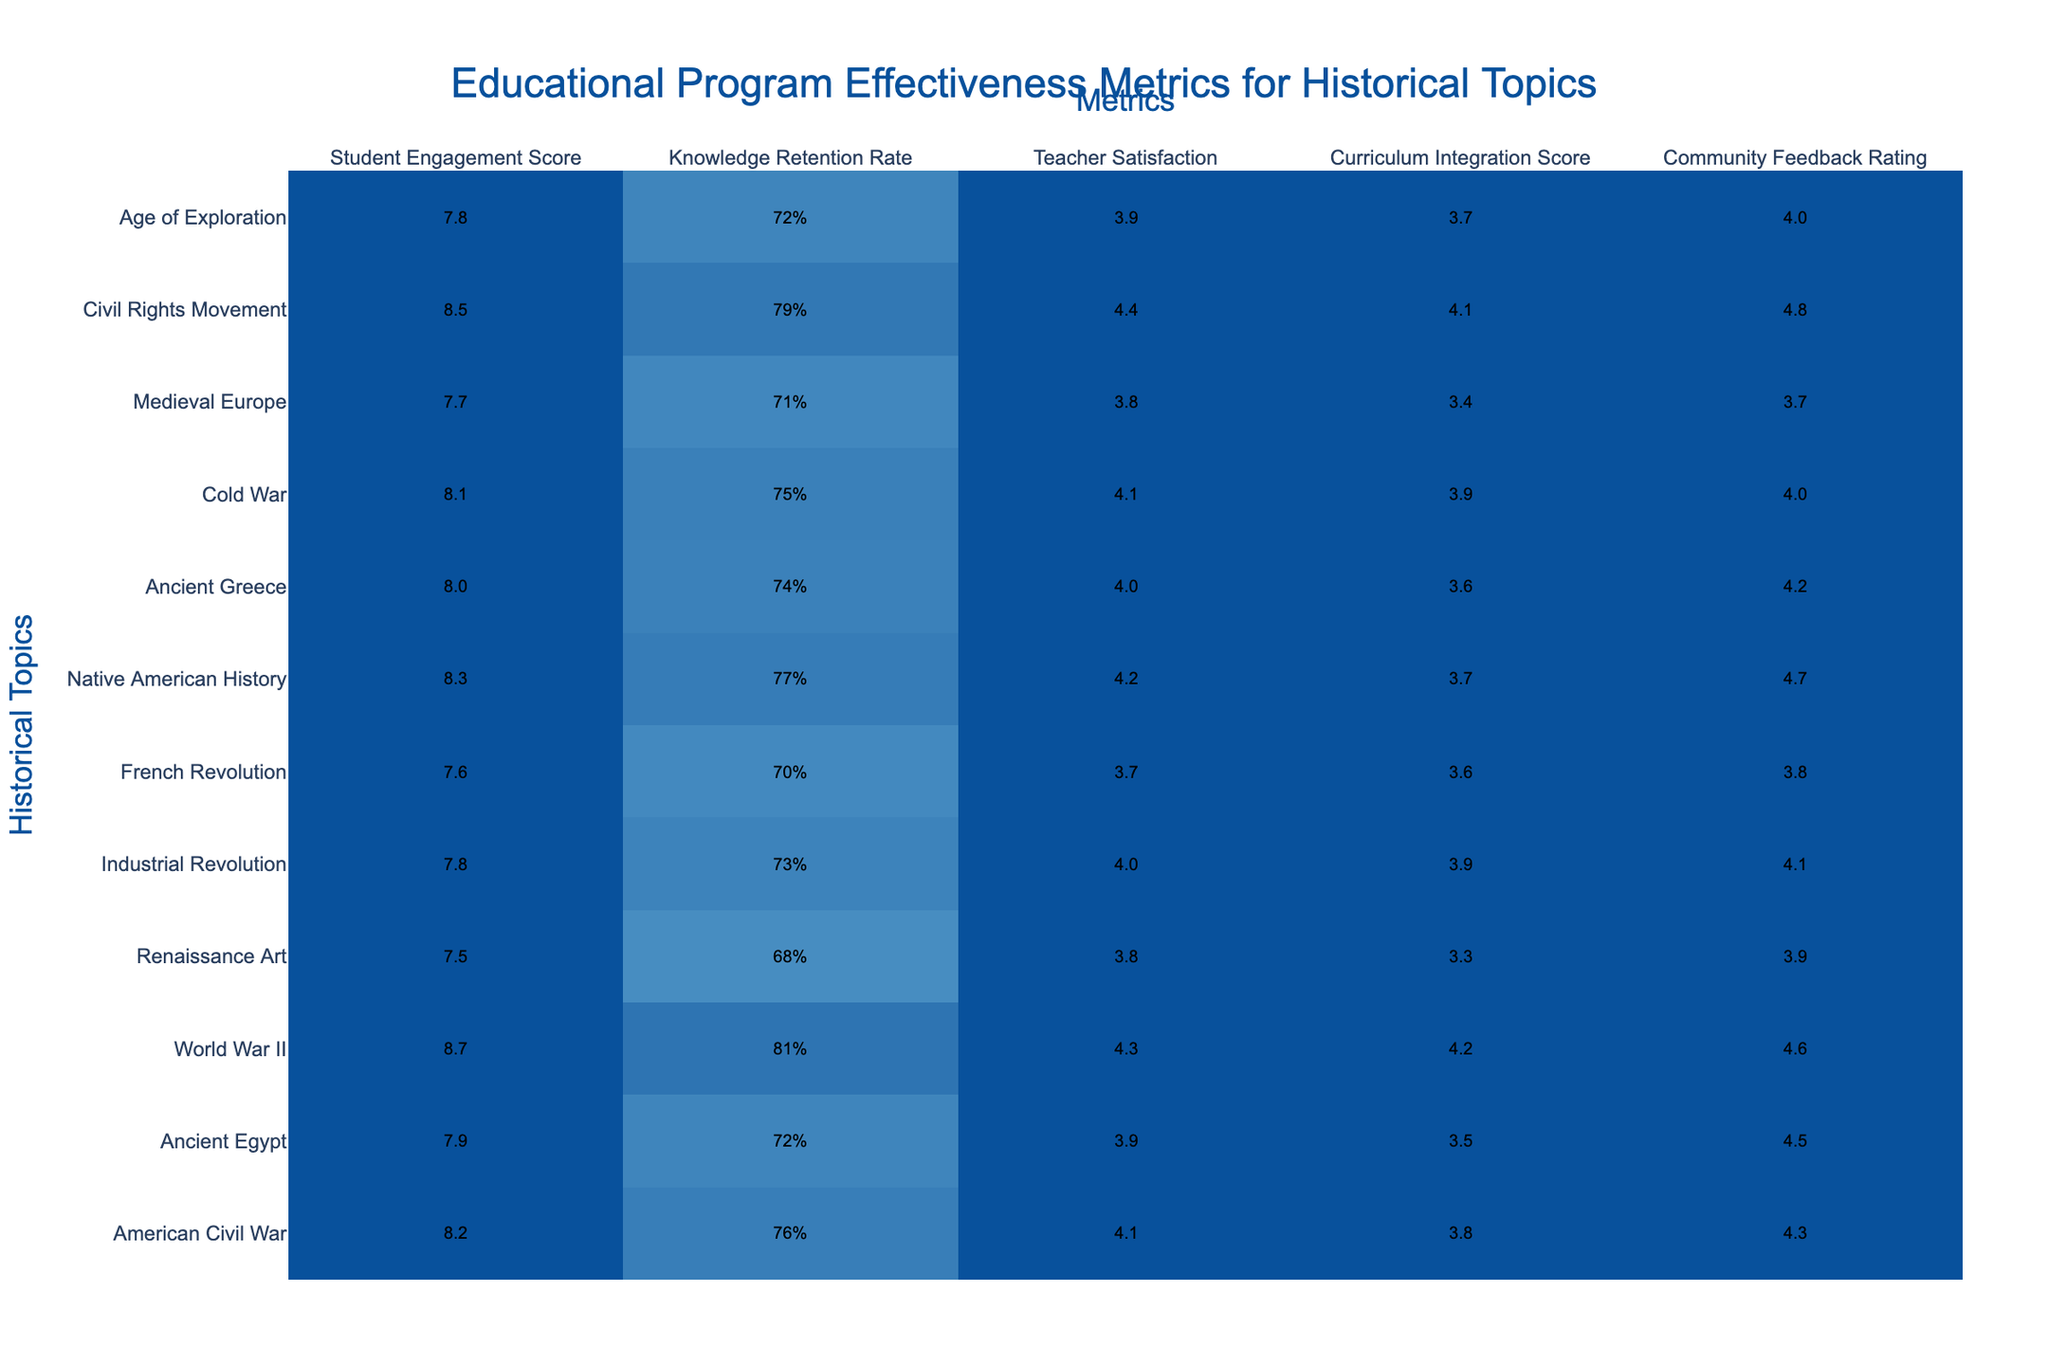What is the Student Engagement Score for World War II? The Student Engagement Score for World War II can be directly retrieved from the table, where it is listed as 8.7.
Answer: 8.7 Which historical topic has the highest Teacher Satisfaction rating? By comparing the Teacher Satisfaction ratings in the table, Civil Rights Movement has the highest rating at 4.4.
Answer: Civil Rights Movement What is the average Knowledge Retention Rate across all historical topics? To find the average Knowledge Retention Rate, convert each percentage to a decimal, sum them up, and then divide by the total number of topics: (0.76 + 0.72 + 0.81 + 0.68 + 0.73 + 0.70 + 0.77 + 0.74 + 0.75 + 0.71 + 0.79 + 0.72) / 12 = 0.7491667, which is approximately 0.75 or 75%.
Answer: 75% Is the Community Feedback Rating for Ancient Greece greater than that for the Renaissance Art? By checking the Community Feedback Ratings, Ancient Greece has a rating of 4.2, while Renaissance Art has 3.9. Therefore, 4.2 is greater than 3.9.
Answer: Yes Which historical topics have Student Engagement Scores above 8.0? By reviewing the table, the topics with scores above 8.0 are World War II (8.7), Native American History (8.3), and Civil Rights Movement (8.5).
Answer: World War II, Native American History, Civil Rights Movement What is the difference in Teacher Satisfaction between the American Civil War and the French Revolution? The Teacher Satisfaction score for American Civil War is 4.1, and for French Revolution it is 3.7. The difference can be calculated as 4.1 - 3.7 = 0.4.
Answer: 0.4 What percentage of historical topics have a Curriculum Integration Score of 4.0 or higher? From the table, each Curriculum Integration Score is inspected: there are 5 topics (World War II, Civil Rights Movement, American Civil War, Native American History, and Industrial Revolution) out of 12 that meet or exceed a score of 4.0. Thus, (5/12) * 100 = approximately 41.67%.
Answer: Approximately 41.67% Which two historical topics have the closest Community Feedback Ratings? Comparing the Community Feedback Ratings, the closest values are French Revolution (3.8) and Medieval Europe (3.7) with a difference of 0.1.
Answer: French Revolution and Medieval Europe What is the highest Knowledge Retention Rate and which historical topic does it correspond to? The Knowledge Retention Rate is highest at 81%, which corresponds to World War II.
Answer: World War II, 81% Do any historical topics have both a Student Engagement Score and a Community Feedback Rating below 8.0? Analyzing the table shows that Renaissance Art (7.5 and 3.9) and French Revolution (7.6 and 3.8) both have scores below 8.0 for both metrics.
Answer: Yes Calculate the median of the Teacher Satisfaction ratings. Organizing the Teacher Satisfaction Ratings from lowest to highest: 3.7, 3.8, 3.8, 3.9, 4.0, 4.1, 4.1, 4.2, 4.3, 4.4, 4.4. The median is the average of the 6th and 7th values: (4.1 + 4.1) / 2 = 4.1.
Answer: 4.1 